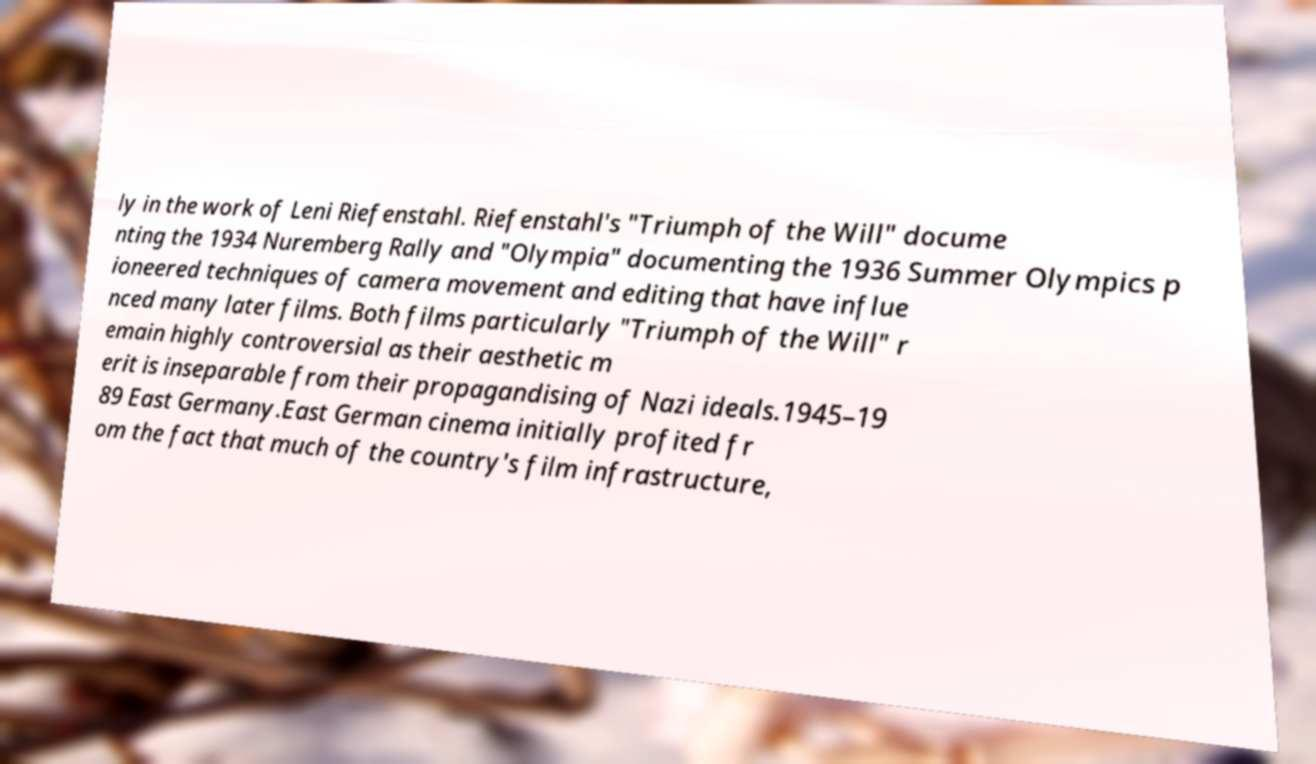Can you read and provide the text displayed in the image?This photo seems to have some interesting text. Can you extract and type it out for me? ly in the work of Leni Riefenstahl. Riefenstahl's "Triumph of the Will" docume nting the 1934 Nuremberg Rally and "Olympia" documenting the 1936 Summer Olympics p ioneered techniques of camera movement and editing that have influe nced many later films. Both films particularly "Triumph of the Will" r emain highly controversial as their aesthetic m erit is inseparable from their propagandising of Nazi ideals.1945–19 89 East Germany.East German cinema initially profited fr om the fact that much of the country's film infrastructure, 